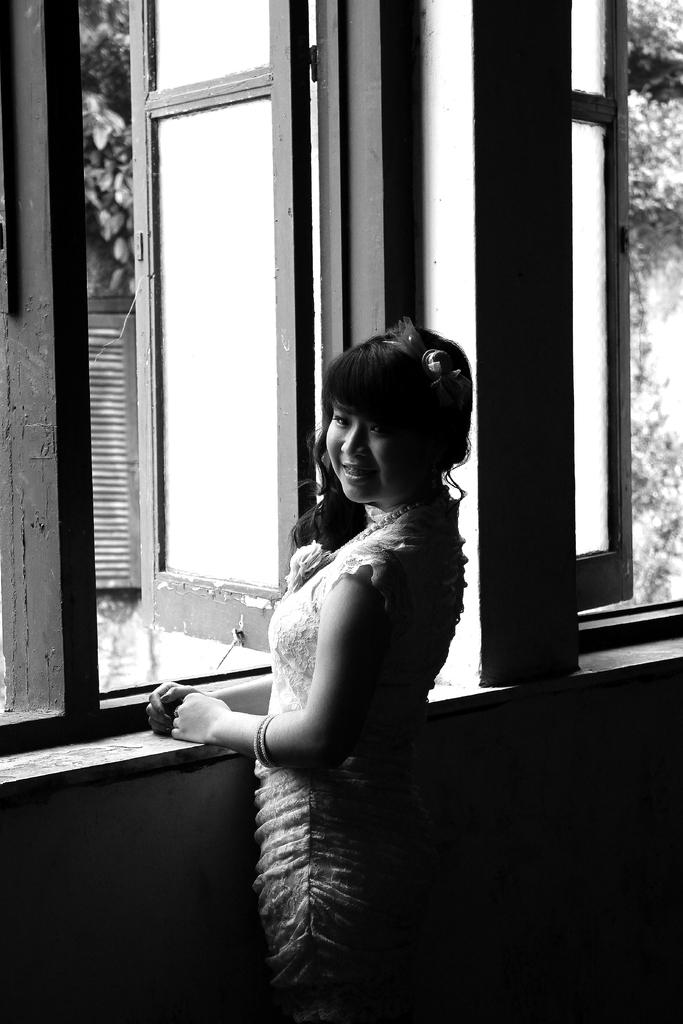Who is present in the image? There is a woman in the image. What is the woman doing in the image? The woman is standing and smiling. What can be seen through the windows in the image? The image does not provide enough detail to determine what can be seen through the windows. What is the color scheme of the image? The image is black and white. How would you describe the overall lighting in the image? The image appears dark. What type of jam is the woman holding in the image? There is no jam present in the image. Can you see any worms crawling on the windows in the image? There are no worms visible in the image. Is there a jellyfish swimming in the background of the image? There is no jellyfish present in the image. 